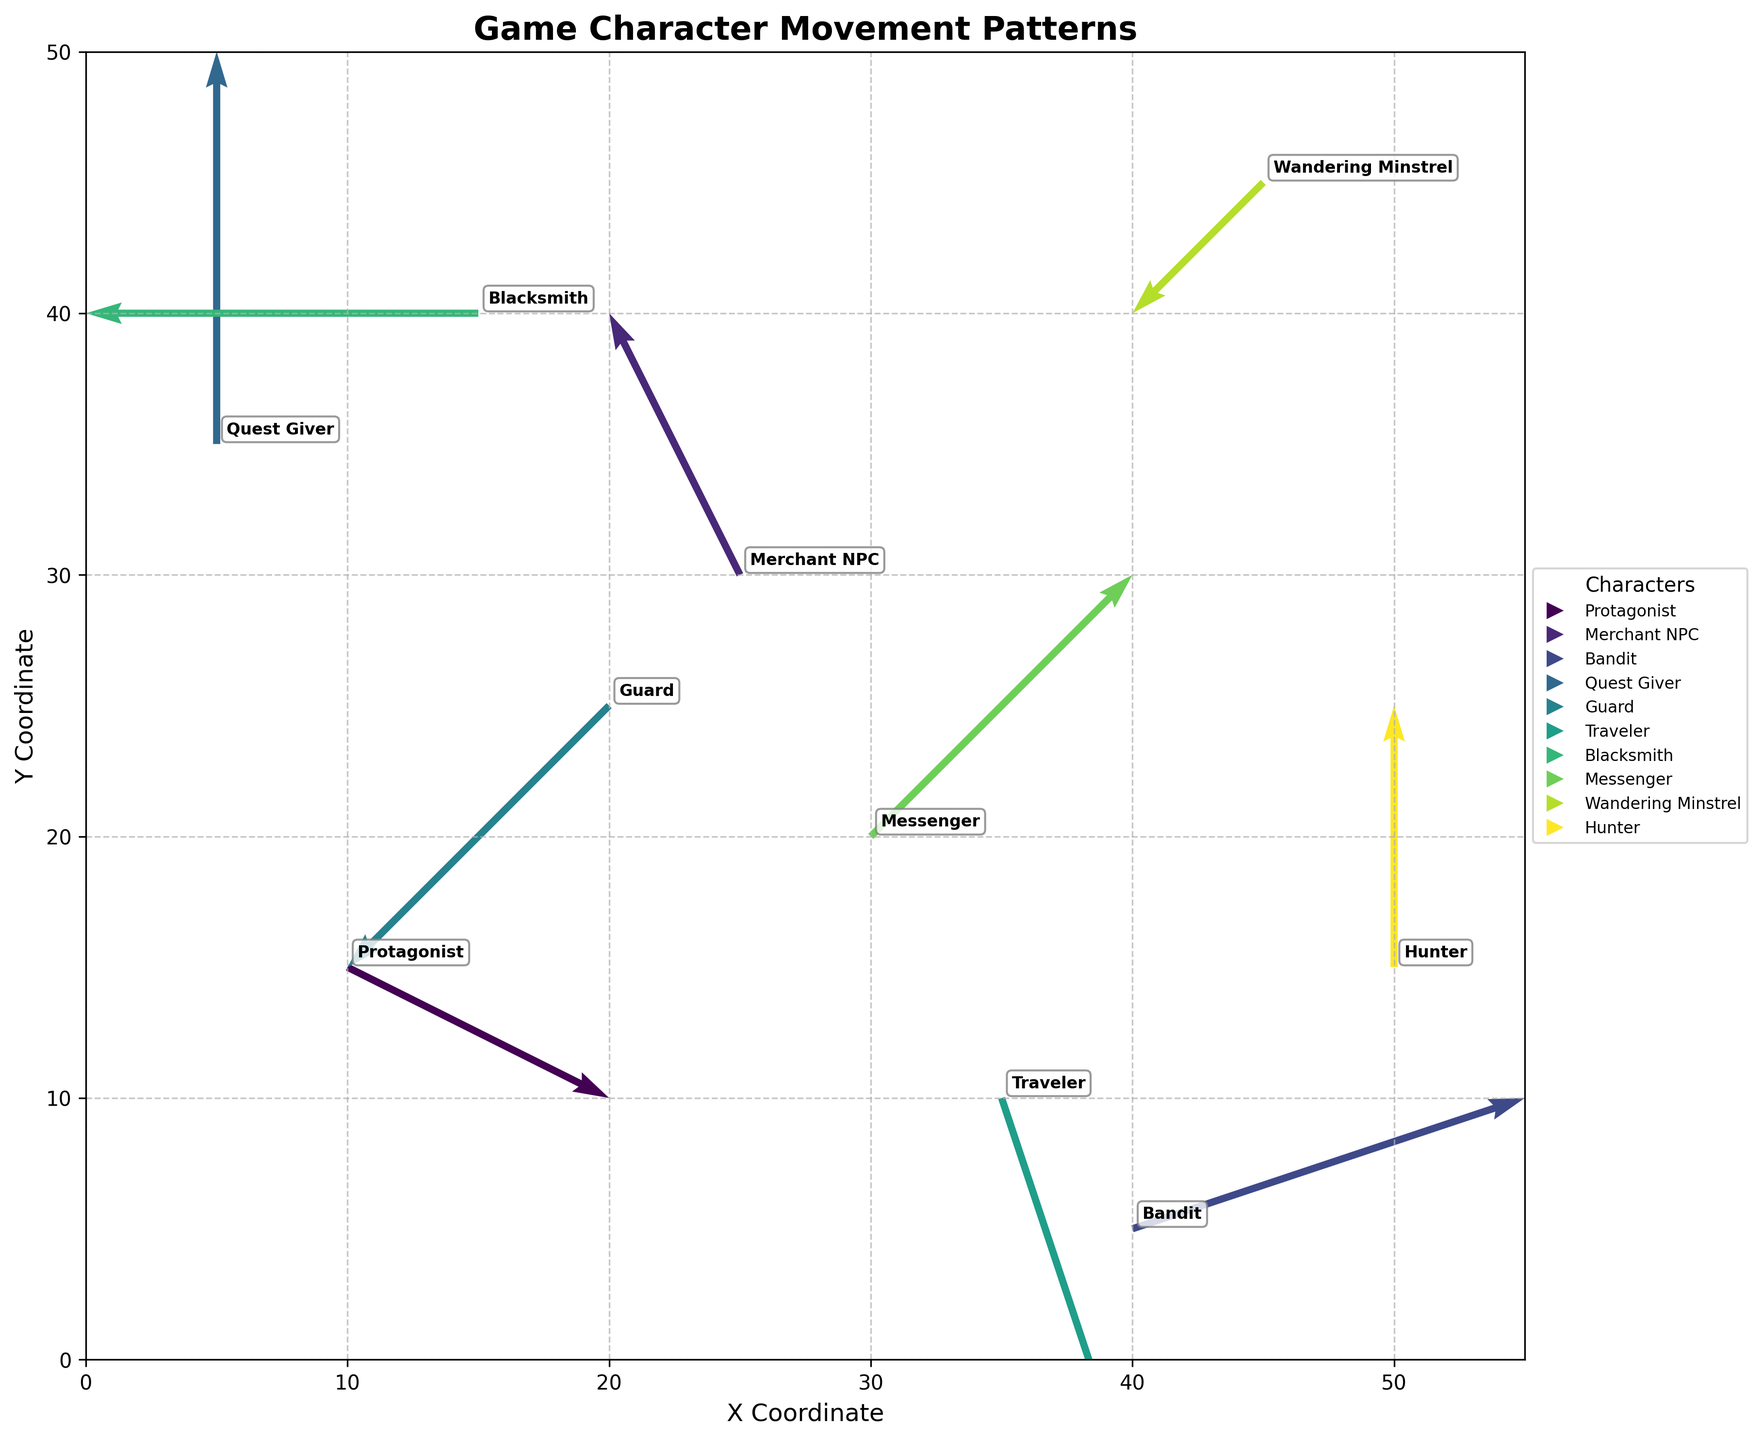1. What is the title of the figure? The title of the figure is displayed at the top center of the plot.
Answer: Game Character Movement Patterns 2. How many characters are represented in the figure? Each quiver represents a character's movement, and their names are annotated near their respective arrows. By counting the distinct names on the plot, we can determine the number of characters.
Answer: 10 3. Which character has the highest positive x-direction movement? The positive x-direction movement is represented by the u-component of the quiver. By comparing the u-components of all characters, the highest positive value in the x-direction is 3, which belongs to the Bandit.
Answer: Bandit 4. What are the coordinates of the Messenger at the starting point? The coordinates of the starting point for each character are given by the (x, y) values listed in the data frame. The Messenger starts at (30, 20).
Answer: (30, 20) 5. Is there any character that remains stationary in the x-direction or y-direction? To determine if a character remains stationary, we need to check for any u or v components that are zero. The Quest Giver has u = 0, indicating no movement in the x-direction, and the Hunter has u = 0, also showing no movement in the x-direction.
Answer: Quest Giver, Hunter 6. Which character covers the shortest distance in their movement vector? The distance covered by each character can be computed using the Pythagorean theorem: sqrt(u^2 + v^2). By calculating this for each character and finding the minimum value, we determine that the Wandering Minstrel moves the least with a vector of (-1, -1).
Answer: Wandering Minstrel 7. Do any two characters have movement vectors with the exact same magnitude? We compute the magnitude of each movement vector using the Pythagorean theorem: sqrt(u^2 + v^2). Comparing all the magnitudes, we find that none of the characters have the same magnitude for their movement vectors as all values are unique.
Answer: No 8. Which character has moved primarily vertically according to the plot? By evaluating the v-components relative to the u-components, the character with a u value of nearly zero while having a larger v-component has primarily moved vertically. The Quest Giver has a movement vector of (0, 3), indicating a mainly vertical movement.
Answer: Quest Giver 9. What general trend can you observe in the direction of movement of most characters? Observing the direction of the arrows for most characters shows that the majority of characters move diagonally rather than strictly horizontally or vertically.
Answer: Diagonally 10. How does the movement of the Wanderer Minstrel compare to the Guard? The Wandering Minstrel has a movement vector of (-1, -1) and the Guard has a movement vector of (-2, -2). Both characters move in the same general southwest direction, but the Guard has a larger magnitude of movement.
Answer: Same direction, Guard has a larger magnitude 